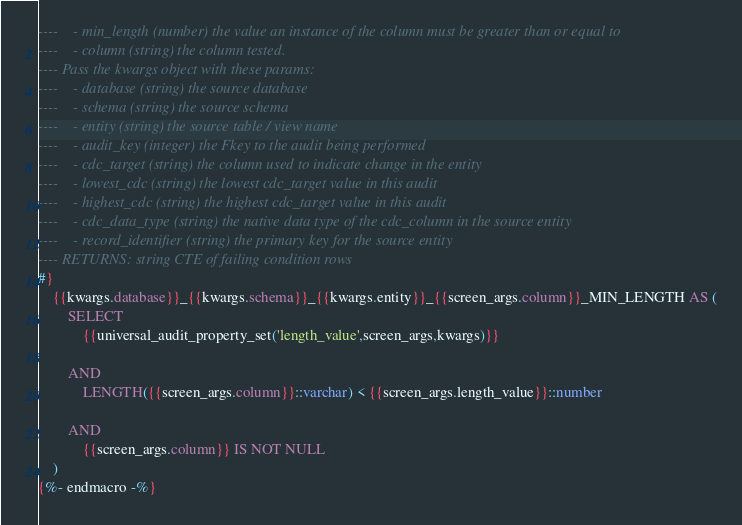Convert code to text. <code><loc_0><loc_0><loc_500><loc_500><_SQL_>----    - min_length (number) the value an instance of the column must be greater than or equal to
----    - column (string) the column tested.
---- Pass the kwargs object with these params:
----    - database (string) the source database
----    - schema (string) the source schema
----    - entity (string) the source table / view name
----    - audit_key (integer) the Fkey to the audit being performed
----    - cdc_target (string) the column used to indicate change in the entity
----    - lowest_cdc (string) the lowest cdc_target value in this audit
----    - highest_cdc (string) the highest cdc_target value in this audit
----    - cdc_data_type (string) the native data type of the cdc_column in the source entity
----    - record_identifier (string) the primary key for the source entity
---- RETURNS: string CTE of failing condition rows
#}
    {{kwargs.database}}_{{kwargs.schema}}_{{kwargs.entity}}_{{screen_args.column}}_MIN_LENGTH AS (
        SELECT
            {{universal_audit_property_set('length_value',screen_args,kwargs)}}

        AND
            LENGTH({{screen_args.column}}::varchar) < {{screen_args.length_value}}::number

        AND
            {{screen_args.column}} IS NOT NULL
    )
{%- endmacro -%}
</code> 